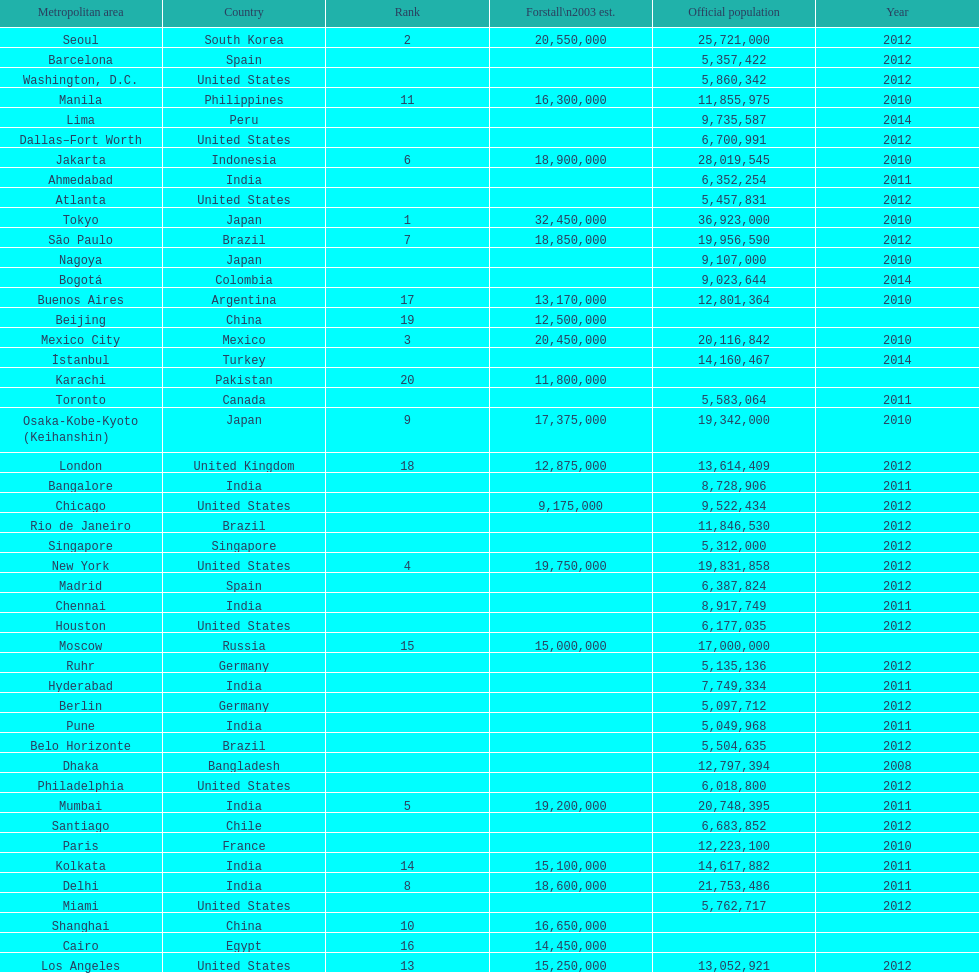Which area is listed above chicago? Chennai. 